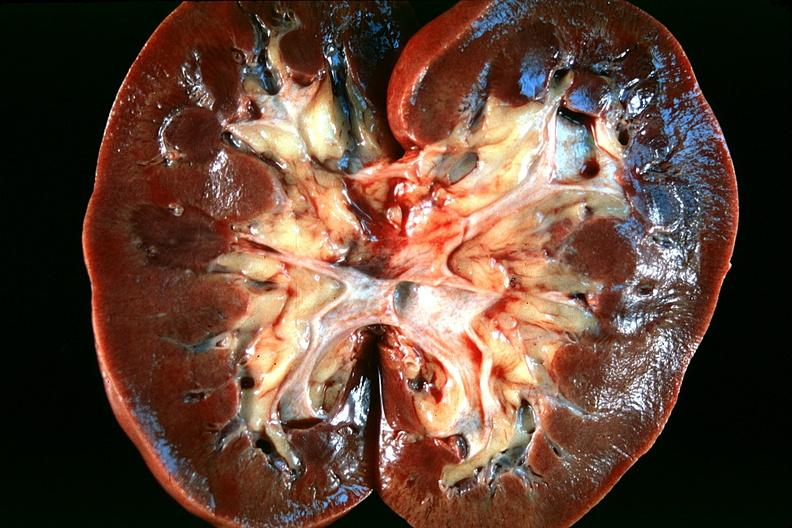what does this image show?
Answer the question using a single word or phrase. Normal kidney 